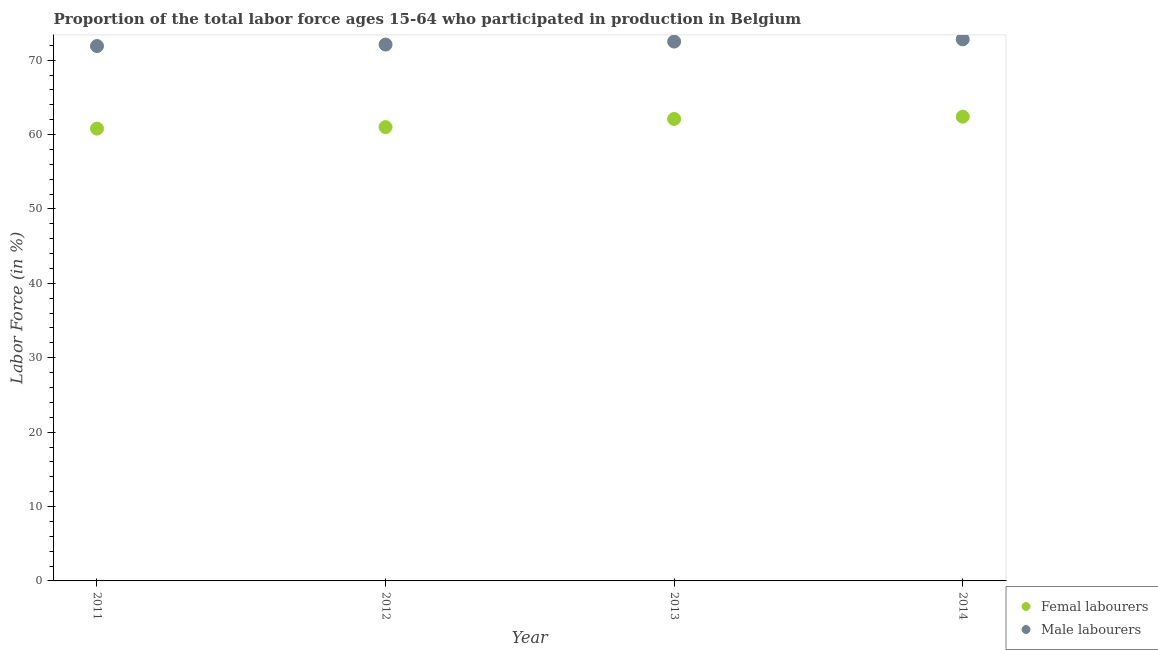How many different coloured dotlines are there?
Your response must be concise. 2. Is the number of dotlines equal to the number of legend labels?
Give a very brief answer. Yes. What is the percentage of male labour force in 2013?
Give a very brief answer. 72.5. Across all years, what is the maximum percentage of male labour force?
Offer a very short reply. 72.8. Across all years, what is the minimum percentage of female labor force?
Make the answer very short. 60.8. In which year was the percentage of female labor force maximum?
Give a very brief answer. 2014. What is the total percentage of male labour force in the graph?
Keep it short and to the point. 289.3. What is the difference between the percentage of male labour force in 2012 and that in 2014?
Make the answer very short. -0.7. What is the difference between the percentage of female labor force in 2014 and the percentage of male labour force in 2012?
Give a very brief answer. -9.7. What is the average percentage of male labour force per year?
Provide a short and direct response. 72.33. In the year 2011, what is the difference between the percentage of female labor force and percentage of male labour force?
Ensure brevity in your answer.  -11.1. What is the ratio of the percentage of male labour force in 2011 to that in 2012?
Keep it short and to the point. 1. What is the difference between the highest and the second highest percentage of male labour force?
Your answer should be very brief. 0.3. What is the difference between the highest and the lowest percentage of female labor force?
Offer a terse response. 1.6. Is the sum of the percentage of male labour force in 2011 and 2012 greater than the maximum percentage of female labor force across all years?
Give a very brief answer. Yes. Does the percentage of male labour force monotonically increase over the years?
Provide a succinct answer. Yes. Is the percentage of female labor force strictly less than the percentage of male labour force over the years?
Make the answer very short. Yes. How many years are there in the graph?
Offer a terse response. 4. Are the values on the major ticks of Y-axis written in scientific E-notation?
Ensure brevity in your answer.  No. Does the graph contain any zero values?
Your response must be concise. No. Does the graph contain grids?
Your answer should be compact. No. What is the title of the graph?
Offer a very short reply. Proportion of the total labor force ages 15-64 who participated in production in Belgium. What is the label or title of the X-axis?
Offer a terse response. Year. What is the Labor Force (in %) in Femal labourers in 2011?
Your answer should be compact. 60.8. What is the Labor Force (in %) in Male labourers in 2011?
Provide a short and direct response. 71.9. What is the Labor Force (in %) of Male labourers in 2012?
Your answer should be compact. 72.1. What is the Labor Force (in %) in Femal labourers in 2013?
Provide a succinct answer. 62.1. What is the Labor Force (in %) in Male labourers in 2013?
Make the answer very short. 72.5. What is the Labor Force (in %) of Femal labourers in 2014?
Ensure brevity in your answer.  62.4. What is the Labor Force (in %) in Male labourers in 2014?
Your answer should be very brief. 72.8. Across all years, what is the maximum Labor Force (in %) in Femal labourers?
Give a very brief answer. 62.4. Across all years, what is the maximum Labor Force (in %) of Male labourers?
Give a very brief answer. 72.8. Across all years, what is the minimum Labor Force (in %) in Femal labourers?
Provide a succinct answer. 60.8. Across all years, what is the minimum Labor Force (in %) of Male labourers?
Offer a terse response. 71.9. What is the total Labor Force (in %) in Femal labourers in the graph?
Offer a terse response. 246.3. What is the total Labor Force (in %) of Male labourers in the graph?
Your answer should be very brief. 289.3. What is the difference between the Labor Force (in %) in Femal labourers in 2011 and that in 2012?
Make the answer very short. -0.2. What is the difference between the Labor Force (in %) of Male labourers in 2011 and that in 2013?
Keep it short and to the point. -0.6. What is the difference between the Labor Force (in %) of Male labourers in 2011 and that in 2014?
Ensure brevity in your answer.  -0.9. What is the difference between the Labor Force (in %) of Femal labourers in 2012 and that in 2013?
Provide a succinct answer. -1.1. What is the difference between the Labor Force (in %) of Male labourers in 2012 and that in 2013?
Give a very brief answer. -0.4. What is the difference between the Labor Force (in %) of Male labourers in 2013 and that in 2014?
Offer a very short reply. -0.3. What is the difference between the Labor Force (in %) of Femal labourers in 2013 and the Labor Force (in %) of Male labourers in 2014?
Keep it short and to the point. -10.7. What is the average Labor Force (in %) of Femal labourers per year?
Keep it short and to the point. 61.58. What is the average Labor Force (in %) in Male labourers per year?
Your response must be concise. 72.33. In the year 2011, what is the difference between the Labor Force (in %) of Femal labourers and Labor Force (in %) of Male labourers?
Make the answer very short. -11.1. In the year 2012, what is the difference between the Labor Force (in %) in Femal labourers and Labor Force (in %) in Male labourers?
Your answer should be very brief. -11.1. What is the ratio of the Labor Force (in %) in Male labourers in 2011 to that in 2012?
Make the answer very short. 1. What is the ratio of the Labor Force (in %) in Femal labourers in 2011 to that in 2013?
Give a very brief answer. 0.98. What is the ratio of the Labor Force (in %) in Male labourers in 2011 to that in 2013?
Your response must be concise. 0.99. What is the ratio of the Labor Force (in %) of Femal labourers in 2011 to that in 2014?
Provide a succinct answer. 0.97. What is the ratio of the Labor Force (in %) in Male labourers in 2011 to that in 2014?
Your answer should be very brief. 0.99. What is the ratio of the Labor Force (in %) in Femal labourers in 2012 to that in 2013?
Give a very brief answer. 0.98. What is the ratio of the Labor Force (in %) of Male labourers in 2012 to that in 2013?
Your answer should be very brief. 0.99. What is the ratio of the Labor Force (in %) of Femal labourers in 2012 to that in 2014?
Provide a short and direct response. 0.98. What is the ratio of the Labor Force (in %) of Male labourers in 2012 to that in 2014?
Keep it short and to the point. 0.99. What is the difference between the highest and the second highest Labor Force (in %) in Male labourers?
Keep it short and to the point. 0.3. What is the difference between the highest and the lowest Labor Force (in %) of Male labourers?
Make the answer very short. 0.9. 